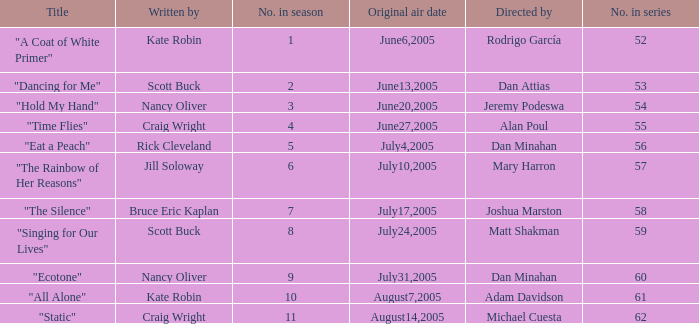What was the name of the episode that was directed by Mary Harron? "The Rainbow of Her Reasons". 